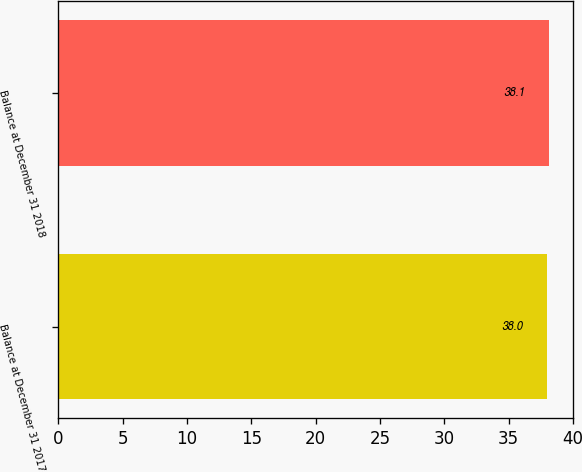Convert chart to OTSL. <chart><loc_0><loc_0><loc_500><loc_500><bar_chart><fcel>Balance at December 31 2017<fcel>Balance at December 31 2018<nl><fcel>38<fcel>38.1<nl></chart> 